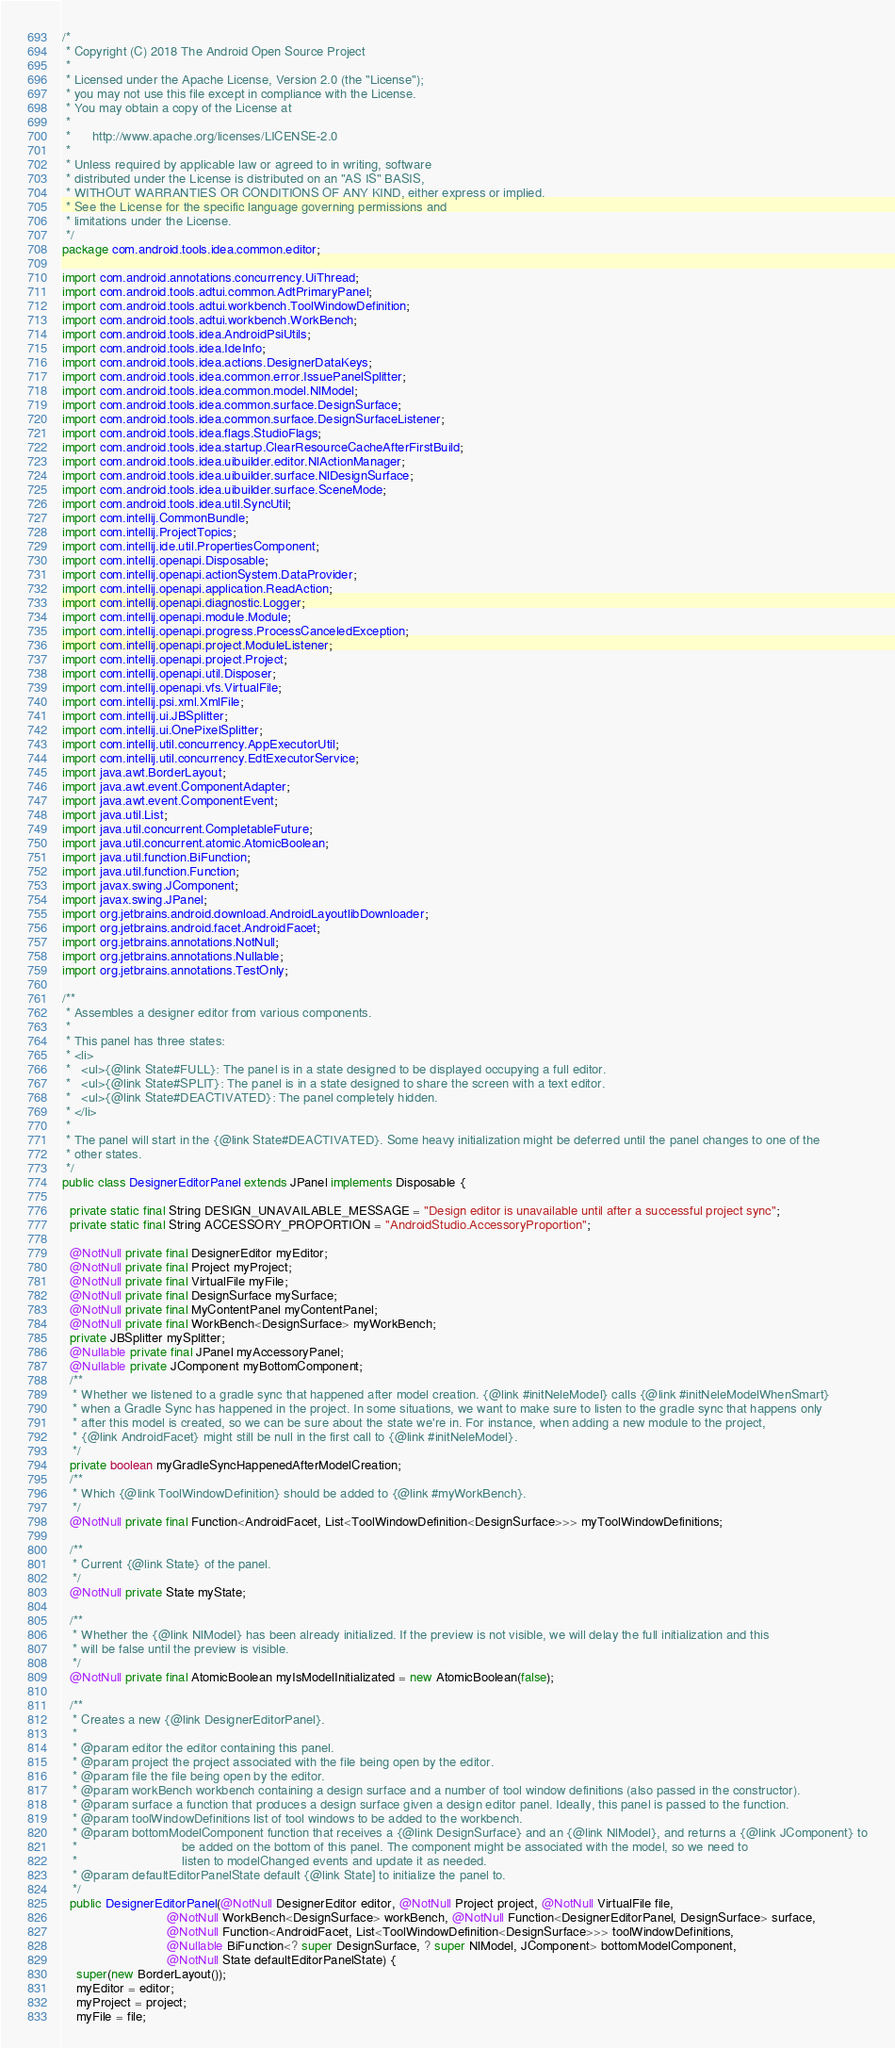<code> <loc_0><loc_0><loc_500><loc_500><_Java_>/*
 * Copyright (C) 2018 The Android Open Source Project
 *
 * Licensed under the Apache License, Version 2.0 (the "License");
 * you may not use this file except in compliance with the License.
 * You may obtain a copy of the License at
 *
 *      http://www.apache.org/licenses/LICENSE-2.0
 *
 * Unless required by applicable law or agreed to in writing, software
 * distributed under the License is distributed on an "AS IS" BASIS,
 * WITHOUT WARRANTIES OR CONDITIONS OF ANY KIND, either express or implied.
 * See the License for the specific language governing permissions and
 * limitations under the License.
 */
package com.android.tools.idea.common.editor;

import com.android.annotations.concurrency.UiThread;
import com.android.tools.adtui.common.AdtPrimaryPanel;
import com.android.tools.adtui.workbench.ToolWindowDefinition;
import com.android.tools.adtui.workbench.WorkBench;
import com.android.tools.idea.AndroidPsiUtils;
import com.android.tools.idea.IdeInfo;
import com.android.tools.idea.actions.DesignerDataKeys;
import com.android.tools.idea.common.error.IssuePanelSplitter;
import com.android.tools.idea.common.model.NlModel;
import com.android.tools.idea.common.surface.DesignSurface;
import com.android.tools.idea.common.surface.DesignSurfaceListener;
import com.android.tools.idea.flags.StudioFlags;
import com.android.tools.idea.startup.ClearResourceCacheAfterFirstBuild;
import com.android.tools.idea.uibuilder.editor.NlActionManager;
import com.android.tools.idea.uibuilder.surface.NlDesignSurface;
import com.android.tools.idea.uibuilder.surface.SceneMode;
import com.android.tools.idea.util.SyncUtil;
import com.intellij.CommonBundle;
import com.intellij.ProjectTopics;
import com.intellij.ide.util.PropertiesComponent;
import com.intellij.openapi.Disposable;
import com.intellij.openapi.actionSystem.DataProvider;
import com.intellij.openapi.application.ReadAction;
import com.intellij.openapi.diagnostic.Logger;
import com.intellij.openapi.module.Module;
import com.intellij.openapi.progress.ProcessCanceledException;
import com.intellij.openapi.project.ModuleListener;
import com.intellij.openapi.project.Project;
import com.intellij.openapi.util.Disposer;
import com.intellij.openapi.vfs.VirtualFile;
import com.intellij.psi.xml.XmlFile;
import com.intellij.ui.JBSplitter;
import com.intellij.ui.OnePixelSplitter;
import com.intellij.util.concurrency.AppExecutorUtil;
import com.intellij.util.concurrency.EdtExecutorService;
import java.awt.BorderLayout;
import java.awt.event.ComponentAdapter;
import java.awt.event.ComponentEvent;
import java.util.List;
import java.util.concurrent.CompletableFuture;
import java.util.concurrent.atomic.AtomicBoolean;
import java.util.function.BiFunction;
import java.util.function.Function;
import javax.swing.JComponent;
import javax.swing.JPanel;
import org.jetbrains.android.download.AndroidLayoutlibDownloader;
import org.jetbrains.android.facet.AndroidFacet;
import org.jetbrains.annotations.NotNull;
import org.jetbrains.annotations.Nullable;
import org.jetbrains.annotations.TestOnly;

/**
 * Assembles a designer editor from various components.
 *
 * This panel has three states:
 * <li>
 *   <ul>{@link State#FULL}: The panel is in a state designed to be displayed occupying a full editor.
 *   <ul>{@link State#SPLIT}: The panel is in a state designed to share the screen with a text editor.
 *   <ul>{@link State#DEACTIVATED}: The panel completely hidden.
 * </li>
 *
 * The panel will start in the {@link State#DEACTIVATED}. Some heavy initialization might be deferred until the panel changes to one of the
 * other states.
 */
public class DesignerEditorPanel extends JPanel implements Disposable {

  private static final String DESIGN_UNAVAILABLE_MESSAGE = "Design editor is unavailable until after a successful project sync";
  private static final String ACCESSORY_PROPORTION = "AndroidStudio.AccessoryProportion";

  @NotNull private final DesignerEditor myEditor;
  @NotNull private final Project myProject;
  @NotNull private final VirtualFile myFile;
  @NotNull private final DesignSurface mySurface;
  @NotNull private final MyContentPanel myContentPanel;
  @NotNull private final WorkBench<DesignSurface> myWorkBench;
  private JBSplitter mySplitter;
  @Nullable private final JPanel myAccessoryPanel;
  @Nullable private JComponent myBottomComponent;
  /**
   * Whether we listened to a gradle sync that happened after model creation. {@link #initNeleModel} calls {@link #initNeleModelWhenSmart}
   * when a Gradle Sync has happened in the project. In some situations, we want to make sure to listen to the gradle sync that happens only
   * after this model is created, so we can be sure about the state we're in. For instance, when adding a new module to the project,
   * {@link AndroidFacet} might still be null in the first call to {@link #initNeleModel}.
   */
  private boolean myGradleSyncHappenedAfterModelCreation;
  /**
   * Which {@link ToolWindowDefinition} should be added to {@link #myWorkBench}.
   */
  @NotNull private final Function<AndroidFacet, List<ToolWindowDefinition<DesignSurface>>> myToolWindowDefinitions;

  /**
   * Current {@link State} of the panel.
   */
  @NotNull private State myState;

  /**
   * Whether the {@link NlModel} has been already initialized. If the preview is not visible, we will delay the full initialization and this
   * will be false until the preview is visible.
   */
  @NotNull private final AtomicBoolean myIsModelInitializated = new AtomicBoolean(false);

  /**
   * Creates a new {@link DesignerEditorPanel}.
   *
   * @param editor the editor containing this panel.
   * @param project the project associated with the file being open by the editor.
   * @param file the file being open by the editor.
   * @param workBench workbench containing a design surface and a number of tool window definitions (also passed in the constructor).
   * @param surface a function that produces a design surface given a design editor panel. Ideally, this panel is passed to the function.
   * @param toolWindowDefinitions list of tool windows to be added to the workbench.
   * @param bottomModelComponent function that receives a {@link DesignSurface} and an {@link NlModel}, and returns a {@link JComponent} to
   *                             be added on the bottom of this panel. The component might be associated with the model, so we need to
   *                             listen to modelChanged events and update it as needed.
   * @param defaultEditorPanelState default {@link State] to initialize the panel to.
   */
  public DesignerEditorPanel(@NotNull DesignerEditor editor, @NotNull Project project, @NotNull VirtualFile file,
                             @NotNull WorkBench<DesignSurface> workBench, @NotNull Function<DesignerEditorPanel, DesignSurface> surface,
                             @NotNull Function<AndroidFacet, List<ToolWindowDefinition<DesignSurface>>> toolWindowDefinitions,
                             @Nullable BiFunction<? super DesignSurface, ? super NlModel, JComponent> bottomModelComponent,
                             @NotNull State defaultEditorPanelState) {
    super(new BorderLayout());
    myEditor = editor;
    myProject = project;
    myFile = file;</code> 